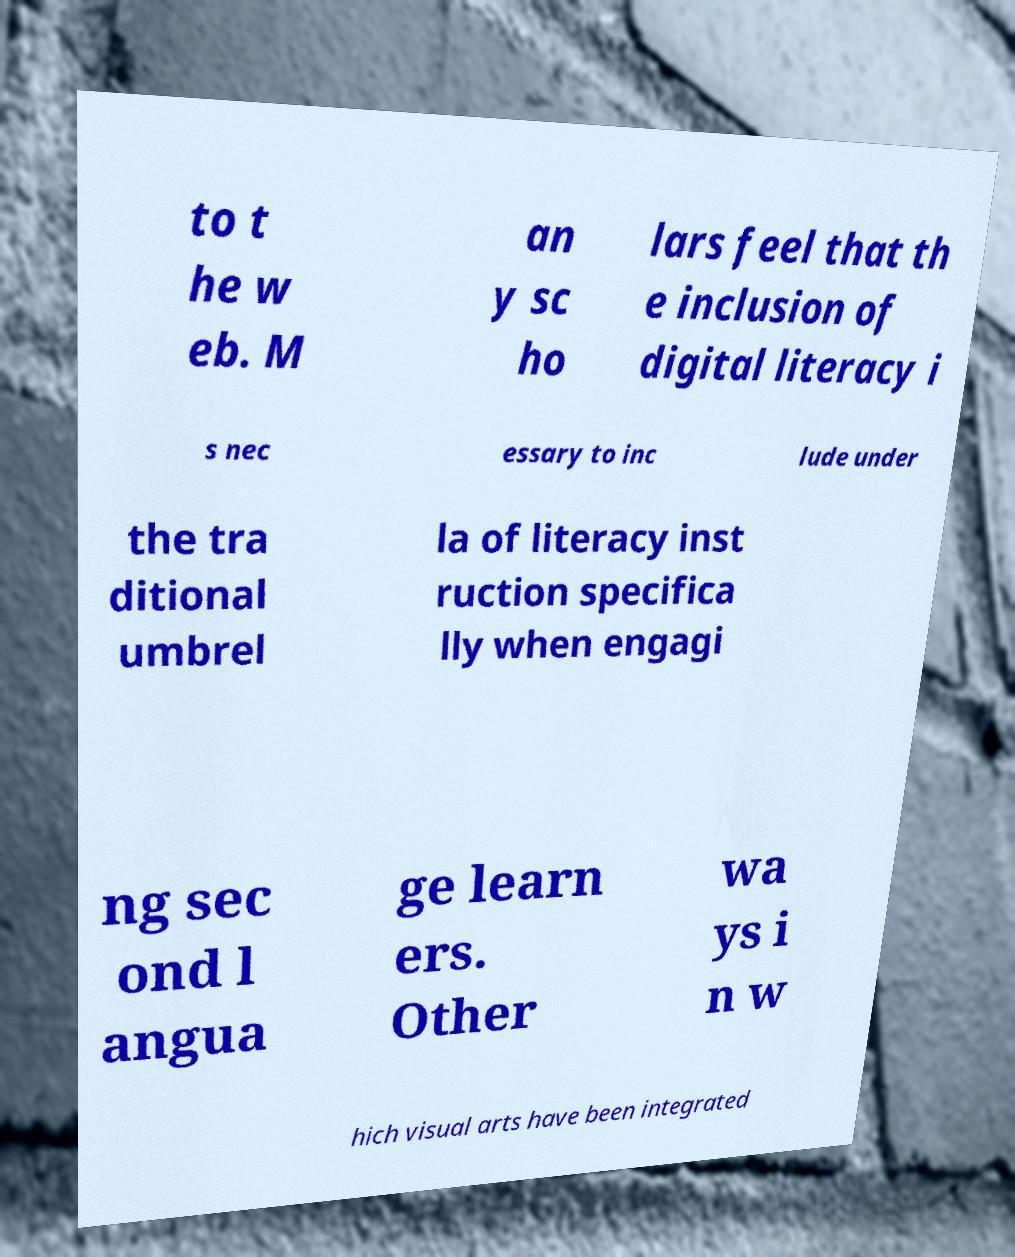For documentation purposes, I need the text within this image transcribed. Could you provide that? to t he w eb. M an y sc ho lars feel that th e inclusion of digital literacy i s nec essary to inc lude under the tra ditional umbrel la of literacy inst ruction specifica lly when engagi ng sec ond l angua ge learn ers. Other wa ys i n w hich visual arts have been integrated 